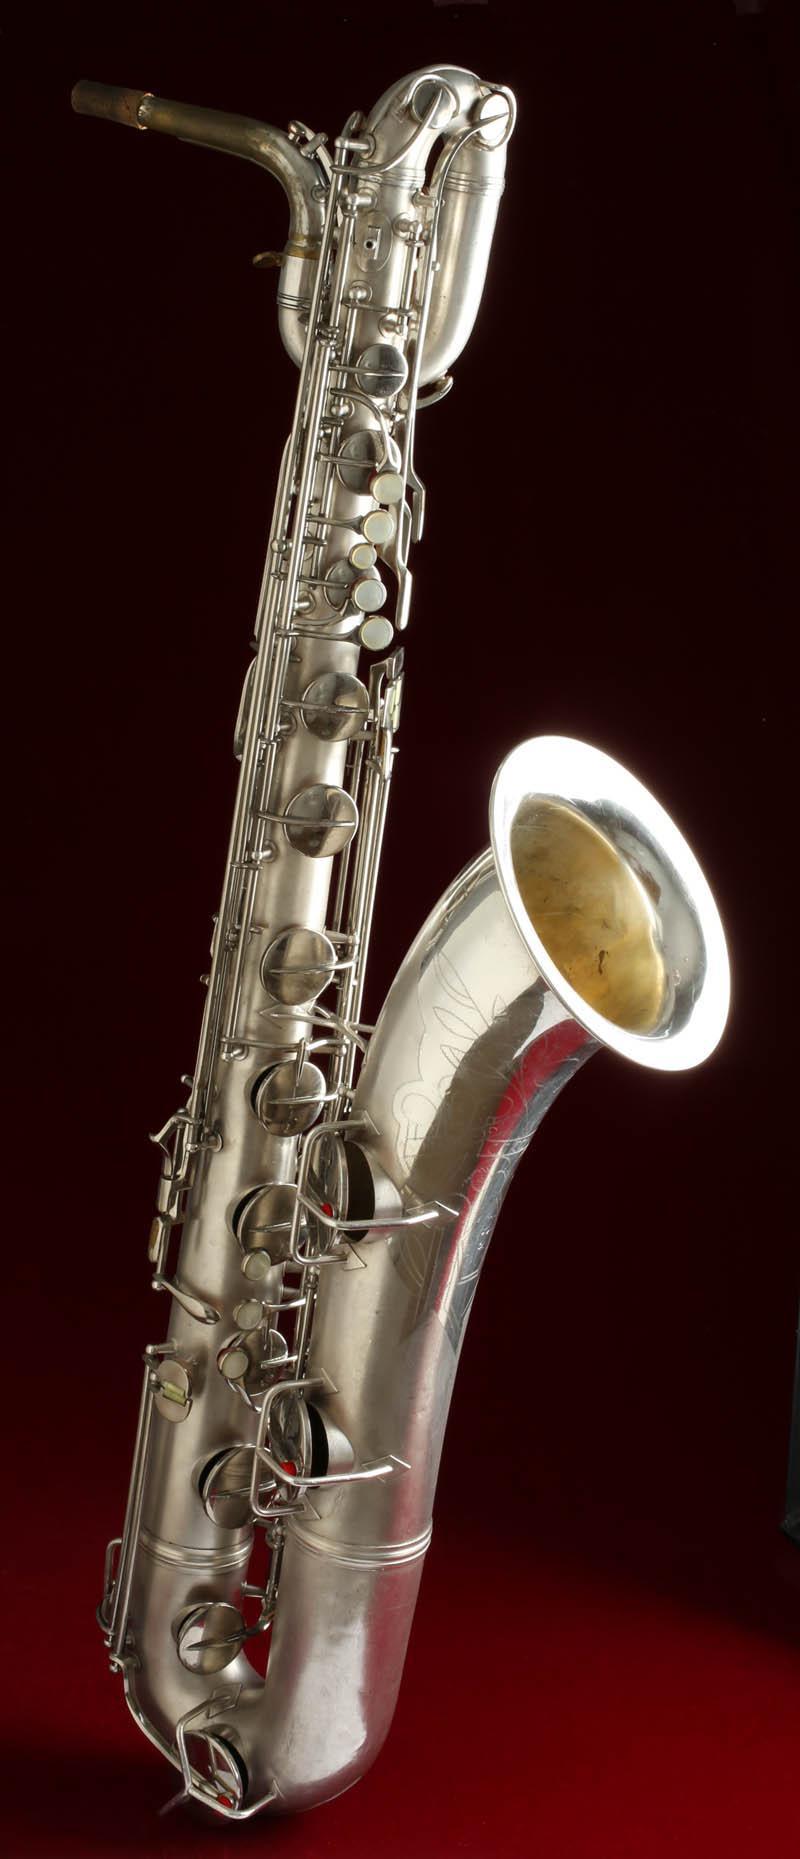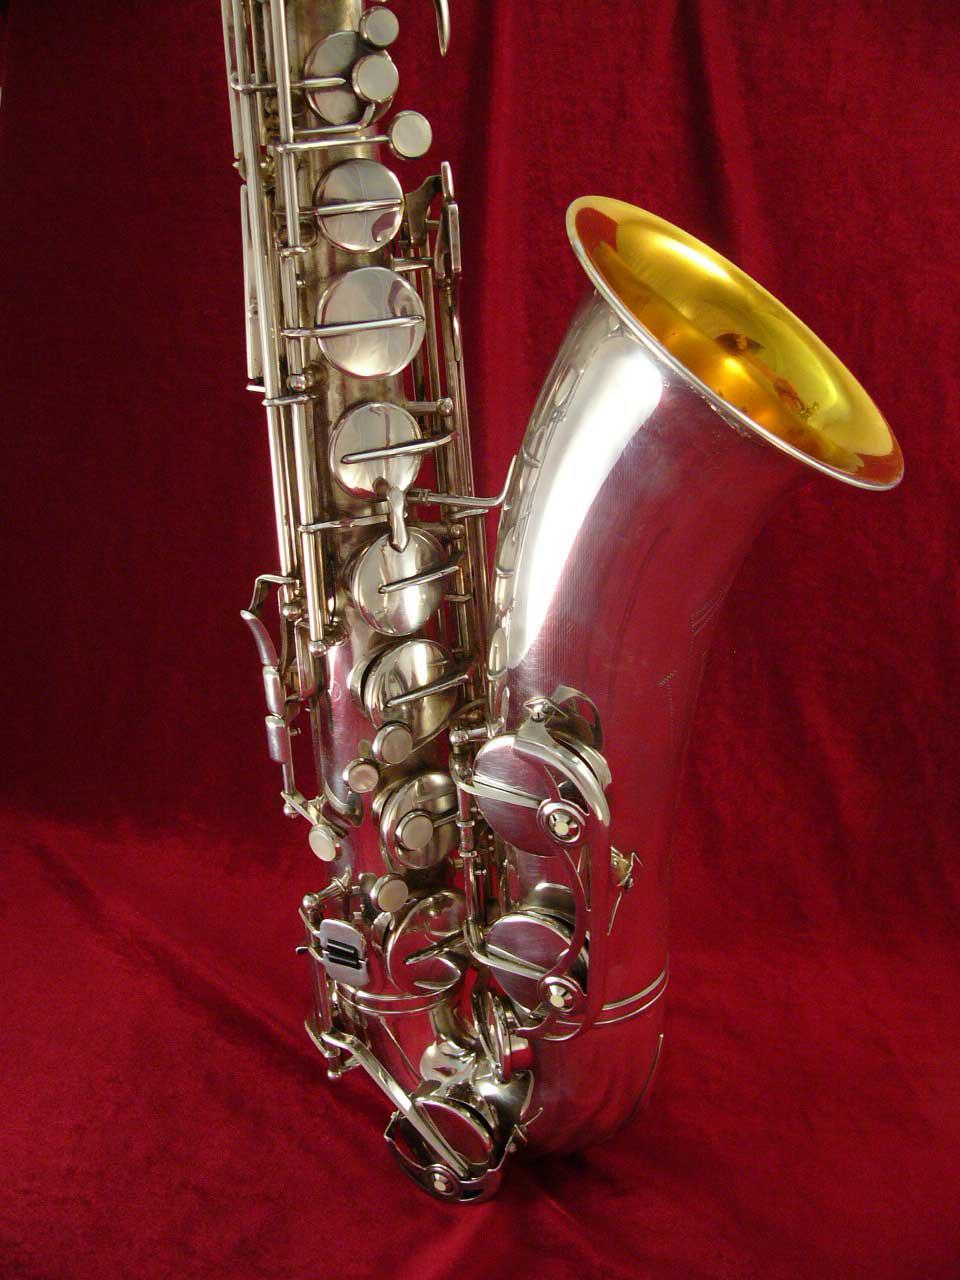The first image is the image on the left, the second image is the image on the right. Given the left and right images, does the statement "The mouthpiece of a saxophone in one image arcs in a curve and then straightens so that it is perpendicular to the instrument body." hold true? Answer yes or no. No. The first image is the image on the left, the second image is the image on the right. For the images displayed, is the sentence "Right image shows a saxophone with a decorative etching on the exterior of its bell end." factually correct? Answer yes or no. No. 